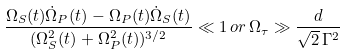Convert formula to latex. <formula><loc_0><loc_0><loc_500><loc_500>\frac { \Omega _ { S } ( t ) \dot { \Omega } _ { P } ( t ) - \Omega _ { P } ( t ) \dot { \Omega } _ { S } ( t ) } { ( \Omega _ { S } ^ { 2 } ( t ) + \Omega _ { P } ^ { 2 } ( t ) ) ^ { 3 / 2 } } \ll 1 \, o r \, \Omega _ { \tau } \gg \frac { d } { \sqrt { 2 } \, \Gamma ^ { 2 } }</formula> 